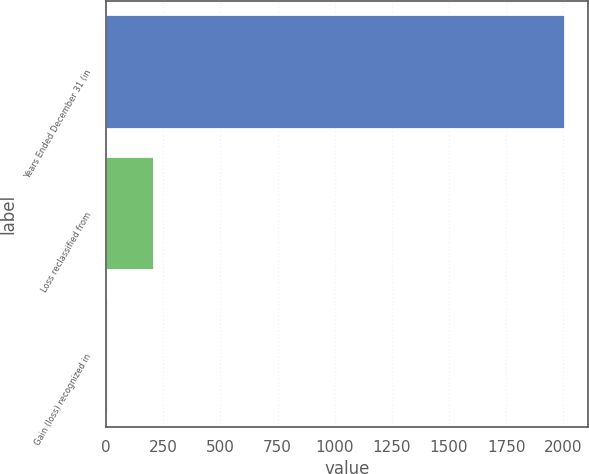Convert chart to OTSL. <chart><loc_0><loc_0><loc_500><loc_500><bar_chart><fcel>Years Ended December 31 (in<fcel>Loss reclassified from<fcel>Gain (loss) recognized in<nl><fcel>2009<fcel>209<fcel>9<nl></chart> 